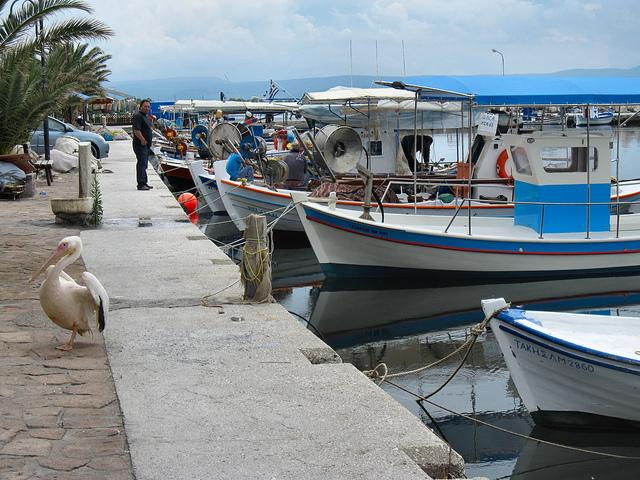What is the name of the large bird? pelican 